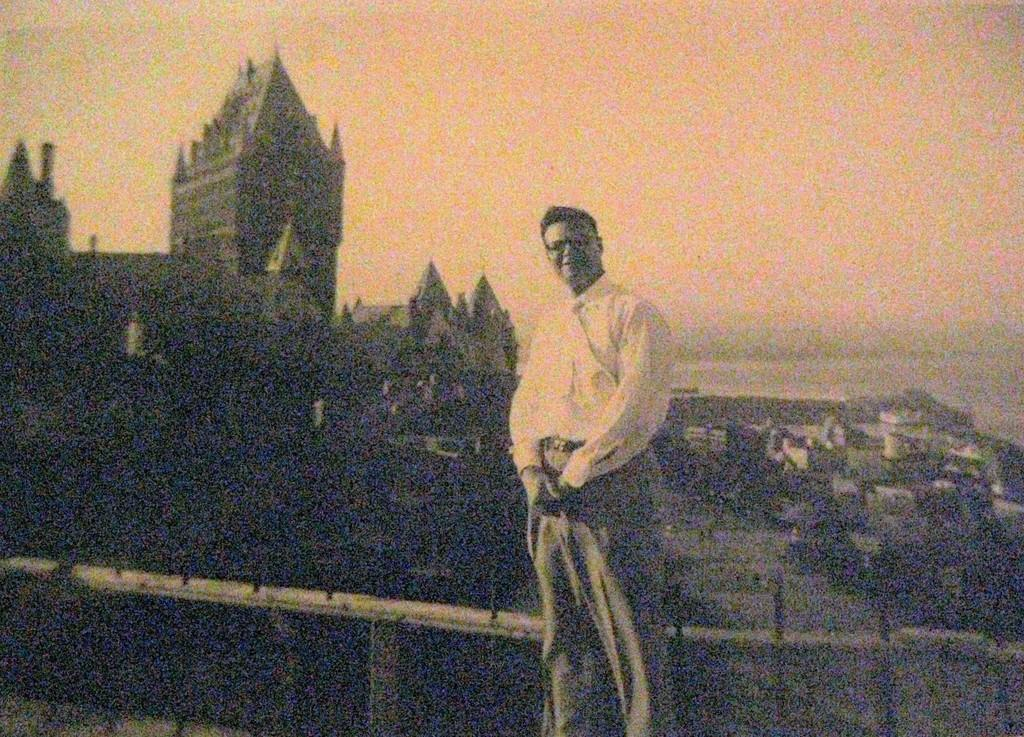Who or what is present in the image? There is a person in the image. What can be seen in the distance behind the person? There are houses in the background of the image. What is visible above the person and houses? The sky is visible in the image. What is separating the person from the houses? There is a fencing in the image. How is the image presented in terms of color? The image is in black and white mode. Is the person wearing a wool sweater during the rainstorm in the image? There is no rainstorm present in the image, and it is not mentioned whether the person is wearing a wool sweater or not. 